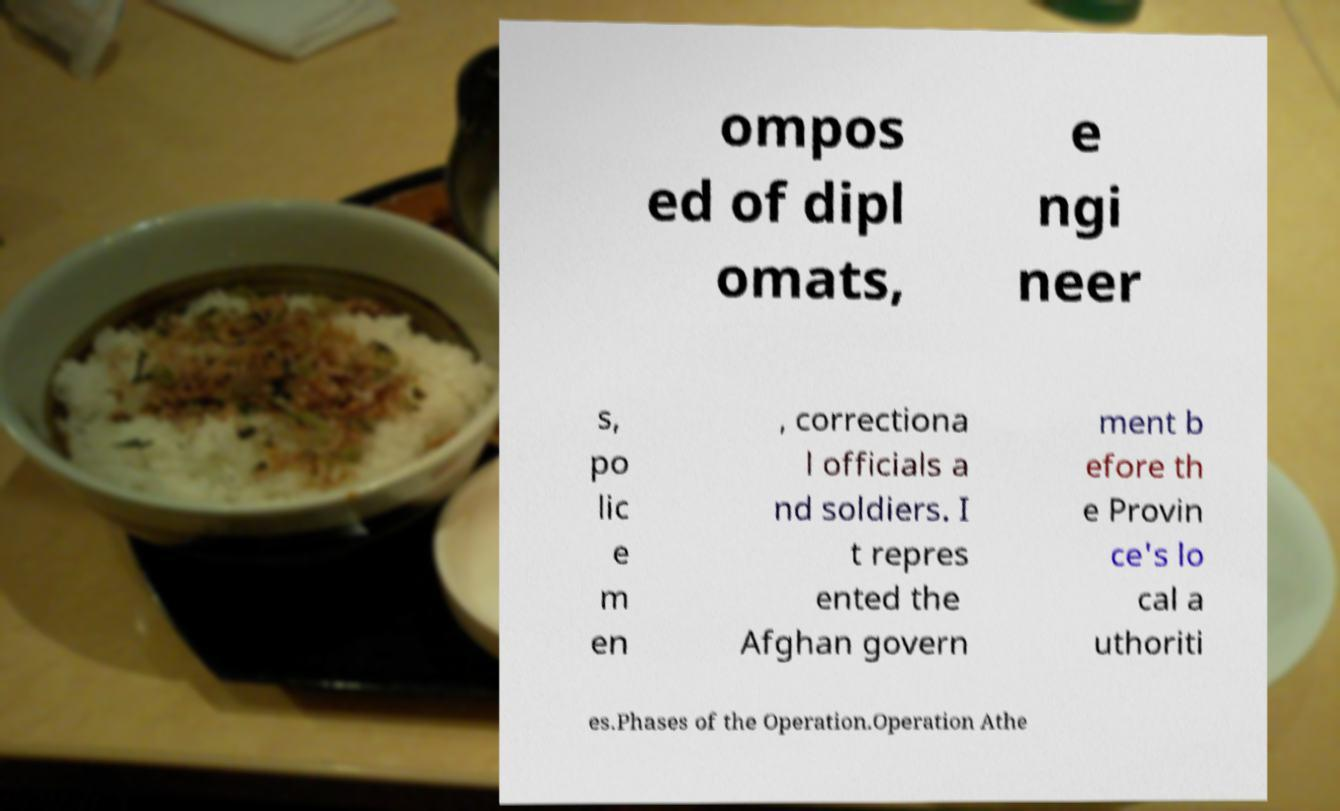Please identify and transcribe the text found in this image. ompos ed of dipl omats, e ngi neer s, po lic e m en , correctiona l officials a nd soldiers. I t repres ented the Afghan govern ment b efore th e Provin ce's lo cal a uthoriti es.Phases of the Operation.Operation Athe 